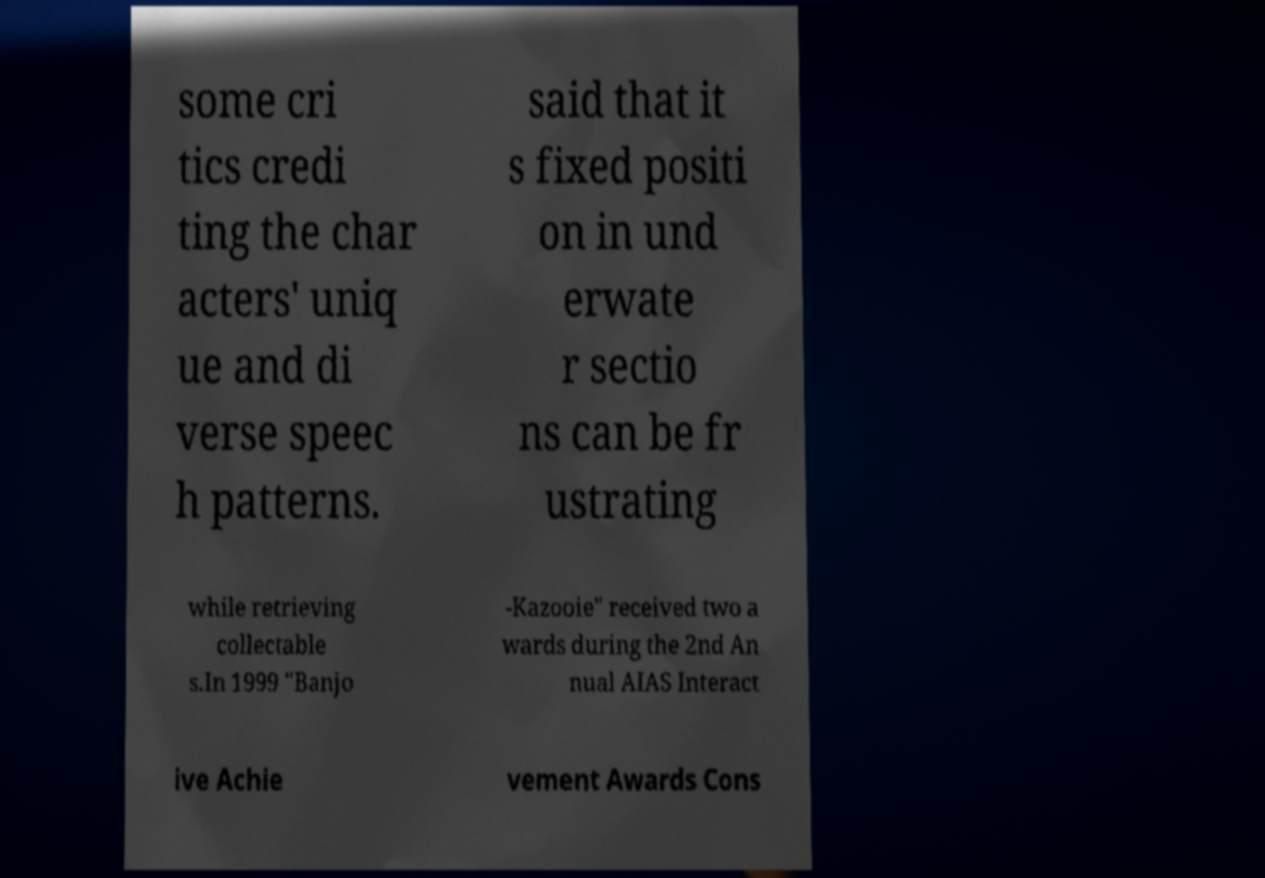What messages or text are displayed in this image? I need them in a readable, typed format. some cri tics credi ting the char acters' uniq ue and di verse speec h patterns. said that it s fixed positi on in und erwate r sectio ns can be fr ustrating while retrieving collectable s.In 1999 "Banjo -Kazooie" received two a wards during the 2nd An nual AIAS Interact ive Achie vement Awards Cons 